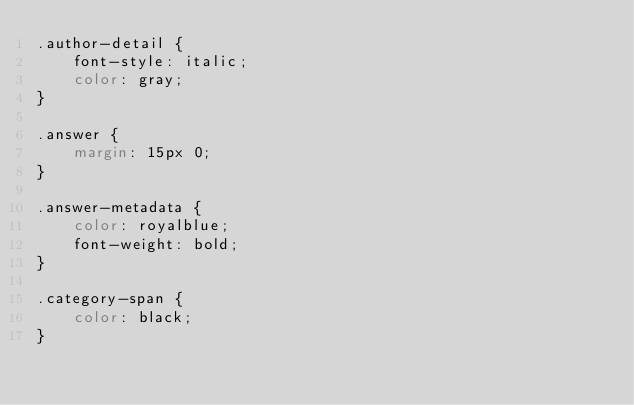<code> <loc_0><loc_0><loc_500><loc_500><_CSS_>.author-detail {
    font-style: italic;
    color: gray;
}

.answer {
    margin: 15px 0;
}

.answer-metadata {
    color: royalblue;
    font-weight: bold;
}

.category-span {
    color: black;
}</code> 